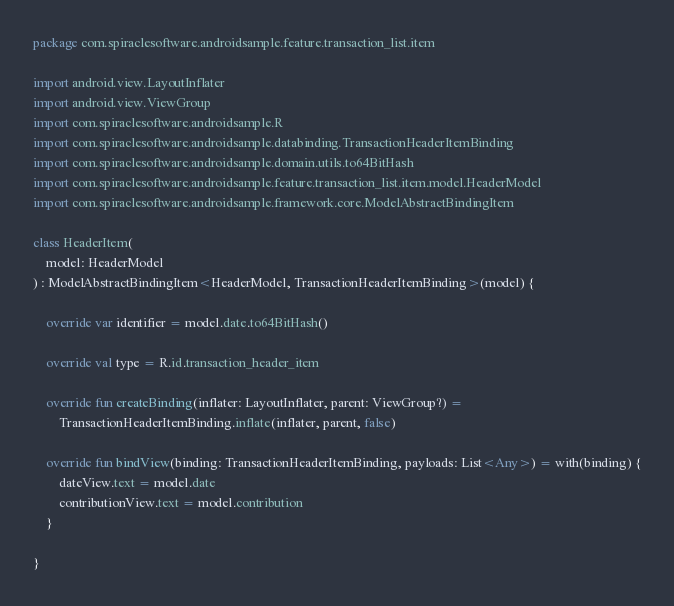<code> <loc_0><loc_0><loc_500><loc_500><_Kotlin_>package com.spiraclesoftware.androidsample.feature.transaction_list.item

import android.view.LayoutInflater
import android.view.ViewGroup
import com.spiraclesoftware.androidsample.R
import com.spiraclesoftware.androidsample.databinding.TransactionHeaderItemBinding
import com.spiraclesoftware.androidsample.domain.utils.to64BitHash
import com.spiraclesoftware.androidsample.feature.transaction_list.item.model.HeaderModel
import com.spiraclesoftware.androidsample.framework.core.ModelAbstractBindingItem

class HeaderItem(
    model: HeaderModel
) : ModelAbstractBindingItem<HeaderModel, TransactionHeaderItemBinding>(model) {

    override var identifier = model.date.to64BitHash()

    override val type = R.id.transaction_header_item

    override fun createBinding(inflater: LayoutInflater, parent: ViewGroup?) =
        TransactionHeaderItemBinding.inflate(inflater, parent, false)

    override fun bindView(binding: TransactionHeaderItemBinding, payloads: List<Any>) = with(binding) {
        dateView.text = model.date
        contributionView.text = model.contribution
    }

}
</code> 